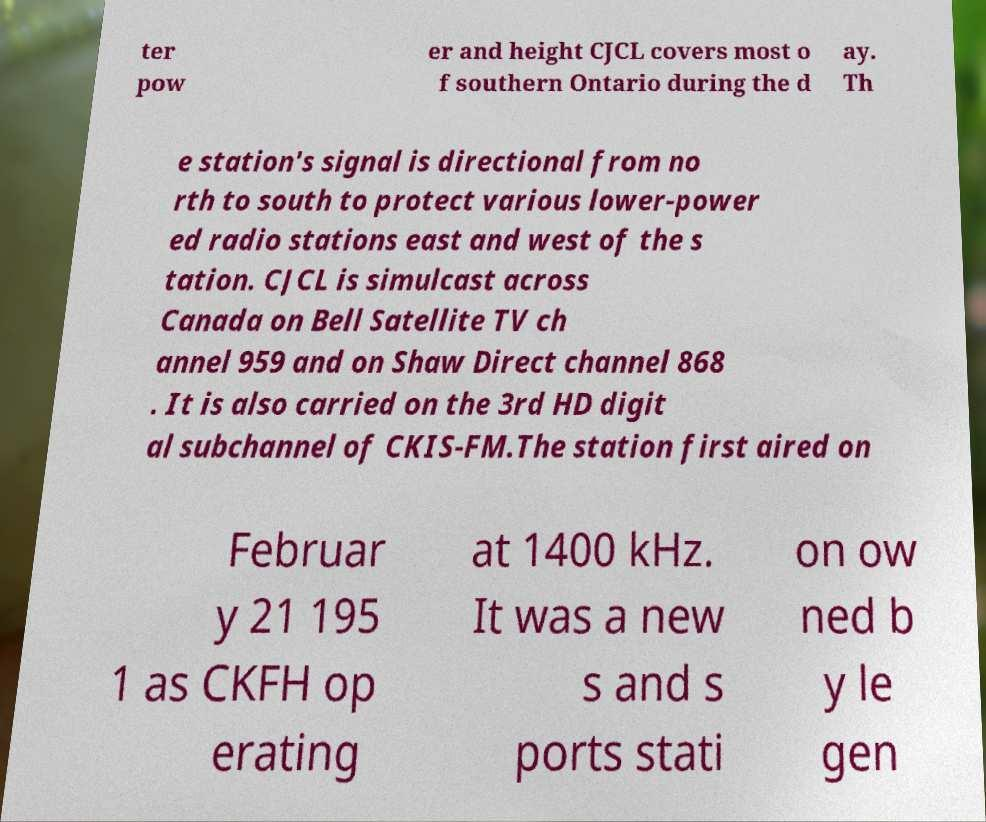Could you assist in decoding the text presented in this image and type it out clearly? ter pow er and height CJCL covers most o f southern Ontario during the d ay. Th e station's signal is directional from no rth to south to protect various lower-power ed radio stations east and west of the s tation. CJCL is simulcast across Canada on Bell Satellite TV ch annel 959 and on Shaw Direct channel 868 . It is also carried on the 3rd HD digit al subchannel of CKIS-FM.The station first aired on Februar y 21 195 1 as CKFH op erating at 1400 kHz. It was a new s and s ports stati on ow ned b y le gen 